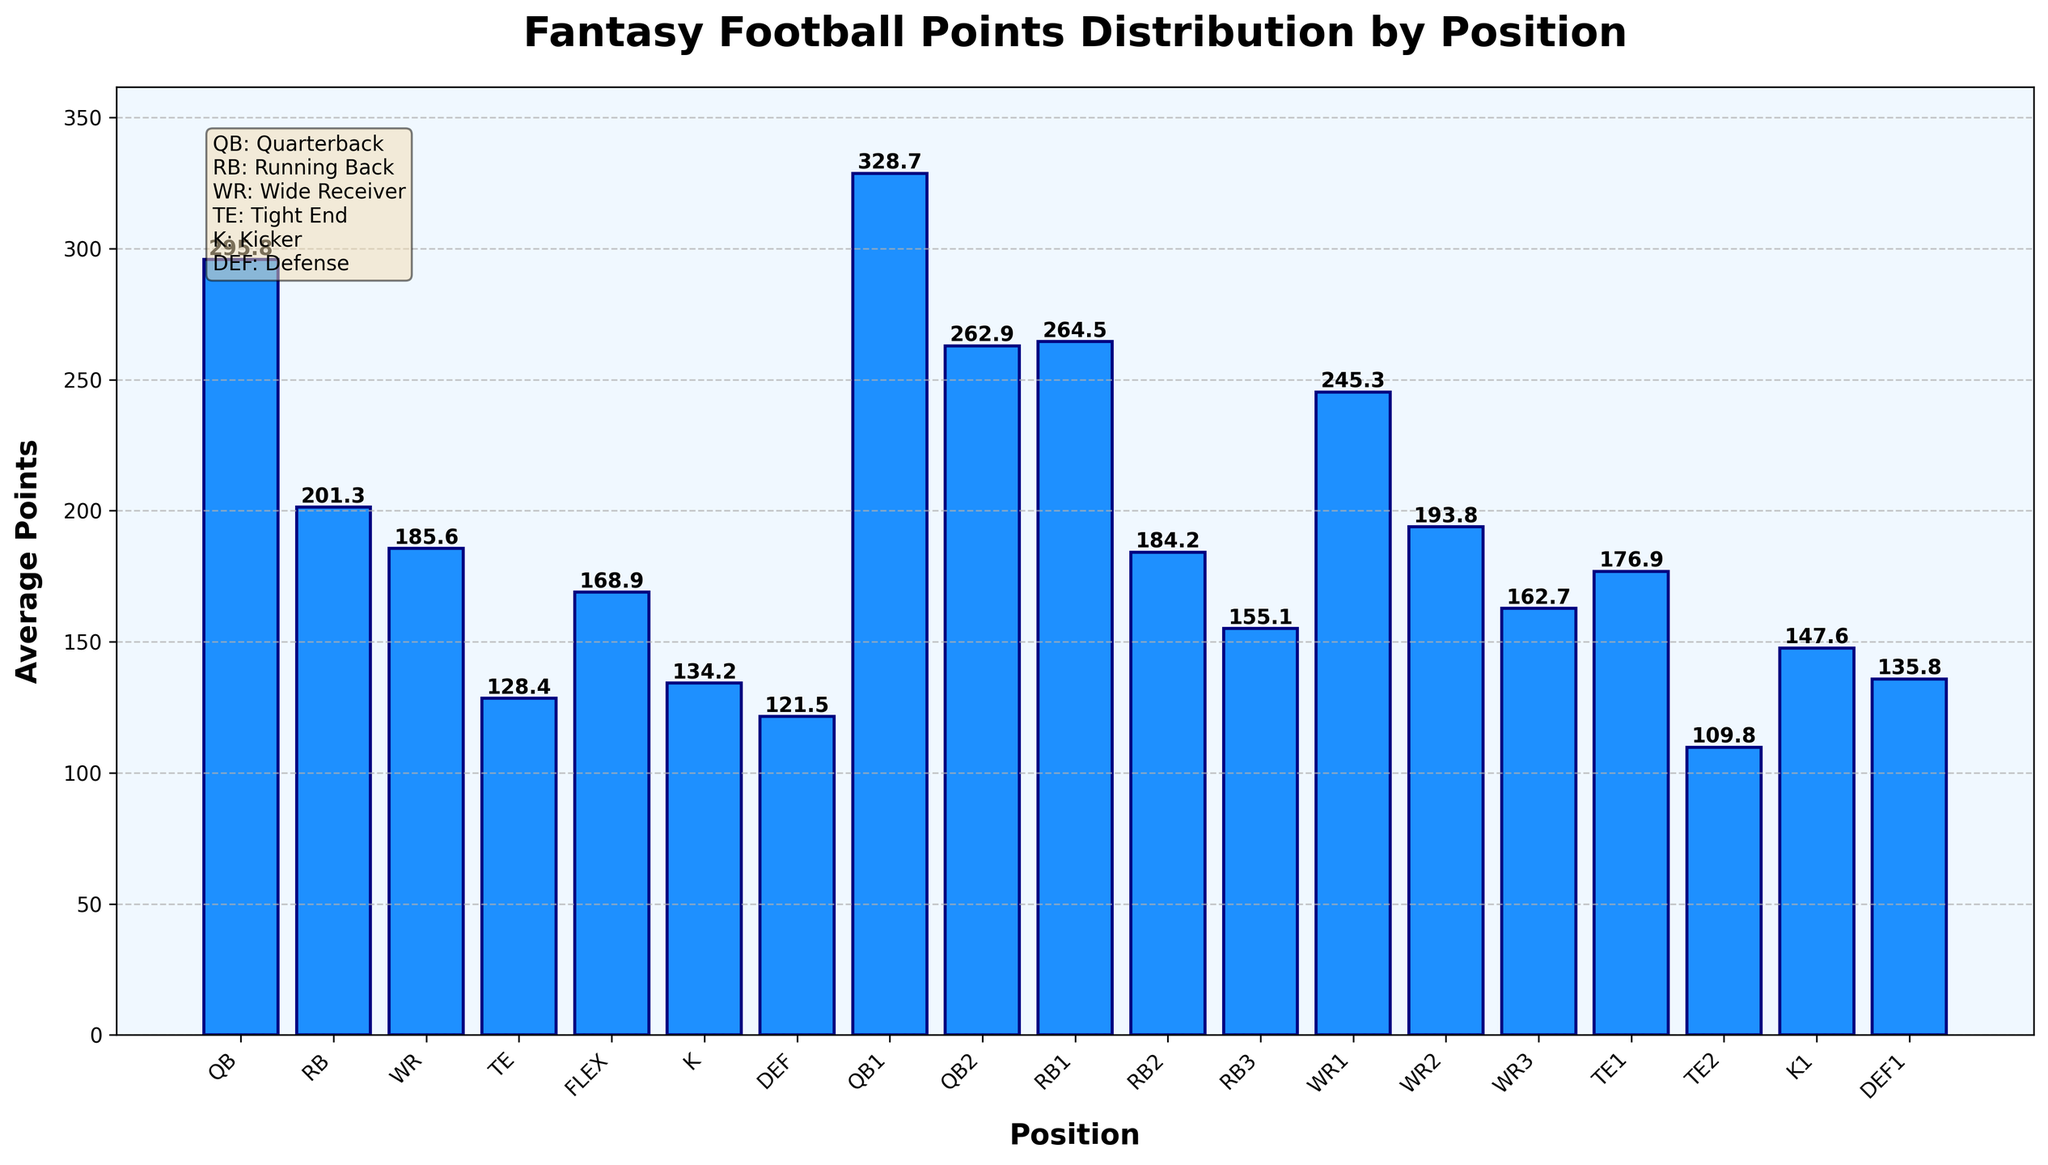Which position has the highest average fantasy football points? The tallest bar represents the Quarterback (QB) position with an average of 295.8 points, indicating it has the highest average fantasy football points.
Answer: Quarterback (QB) Which position has the lowest average fantasy football points? The shortest bar represents the Defense (DEF) position with an average of 121.5 points, indicating it has the lowest average fantasy football points.
Answer: Defense (DEF) What is the difference in average points between QB and RB? The average points for QB is 295.8 and for RB is 201.3. Subtracting these values gives 295.8 - 201.3 = 94.5 points.
Answer: 94.5 Is the average points of WR2 higher or lower than RB1? The average points for WR2 is 193.8, while for RB1 it is 264.5. 193.8 is lower than 264.5, so WR2 has lower average points than RB1.
Answer: Lower Adding the average points of TE and K, do they surpass the average points of QB? The average points for TE is 128.4 and for K it is 134.2. Adding them gives 128.4 + 134.2 = 262.6, which is less than 295.8, the average points for QB.
Answer: No Which position has a higher average points, WR3 or TE1? The average points for WR3 is 162.7, while for TE1 it is 176.9. 176.9 is greater than 162.7, so TE1 has higher average points than WR3.
Answer: TE1 What is the combined average points for the top three positions (QB, RB1, and WR1)? The average points for QB is 295.8, RB1 is 264.5, and WR1 is 245.3. Adding these values gives 295.8 + 264.5 + 245.3 = 805.6 points.
Answer: 805.6 Which has a greater difference in average points, QB1 and QB2 or K1 and DEF1? QB1 has 328.7 and QB2 has 262.9. The difference is 328.7 - 262.9 = 65.8. K1 has 147.6 and DEF1 has 135.8. The difference is 147.6 - 135.8 = 11.8. Comparing them, 65.8 is greater than 11.8.
Answer: QB1 and QB2 Comparing WR1 and WR2, by how many points does WR1 exceed WR2? The average points for WR1 is 245.3 and for WR2 is 193.8. Subtracting these values gives 245.3 - 193.8 = 51.5 points.
Answer: 51.5 Among QB2, RB2, and WR3, which position has the lowest average fantasy football points? The average points for QB2 is 262.9, for RB2 is 184.2, and for WR3 is 162.7. WR3 has the lowest average points among them.
Answer: WR3 